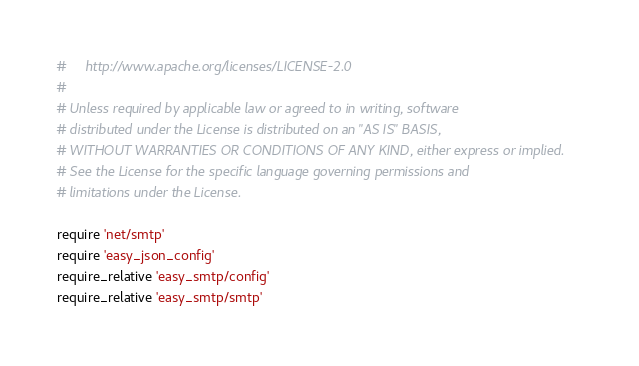Convert code to text. <code><loc_0><loc_0><loc_500><loc_500><_Ruby_>#     http://www.apache.org/licenses/LICENSE-2.0
#
# Unless required by applicable law or agreed to in writing, software
# distributed under the License is distributed on an "AS IS" BASIS,
# WITHOUT WARRANTIES OR CONDITIONS OF ANY KIND, either express or implied.
# See the License for the specific language governing permissions and
# limitations under the License.

require 'net/smtp'
require 'easy_json_config'
require_relative 'easy_smtp/config'
require_relative 'easy_smtp/smtp'
</code> 